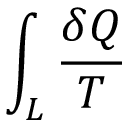<formula> <loc_0><loc_0><loc_500><loc_500>\int _ { L } { \frac { \delta Q } { T } }</formula> 